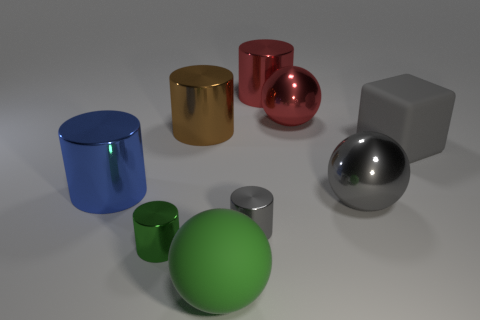Subtract all large gray metal balls. How many balls are left? 2 Subtract all green spheres. Subtract all yellow blocks. How many spheres are left? 2 Subtract all purple cylinders. How many purple blocks are left? 0 Add 1 small yellow metallic balls. How many objects exist? 10 Subtract all red cylinders. How many cylinders are left? 4 Subtract 1 red cylinders. How many objects are left? 8 Subtract all cylinders. How many objects are left? 4 Subtract 2 balls. How many balls are left? 1 Subtract all small red metallic cylinders. Subtract all big red metal cylinders. How many objects are left? 8 Add 3 tiny gray shiny things. How many tiny gray shiny things are left? 4 